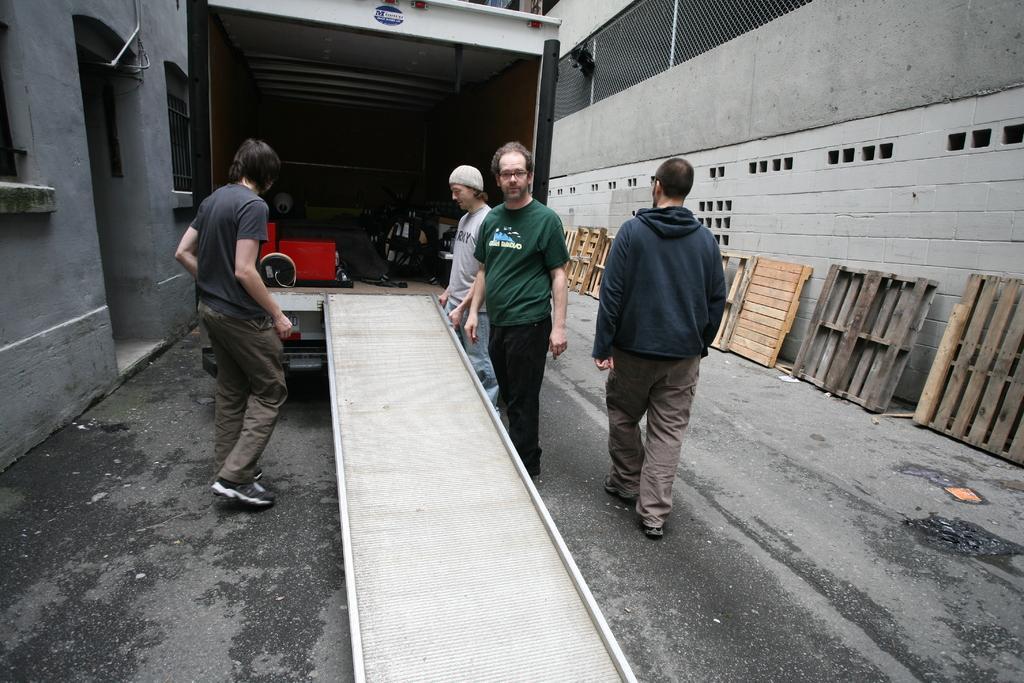In one or two sentences, can you explain what this image depicts? In the center of the image we can see four people are standing. And we can see one vehicle and one inclined plane. Inside the vehicle, we can see some objects. In the background, we can see buildings and a few wooden objects. 